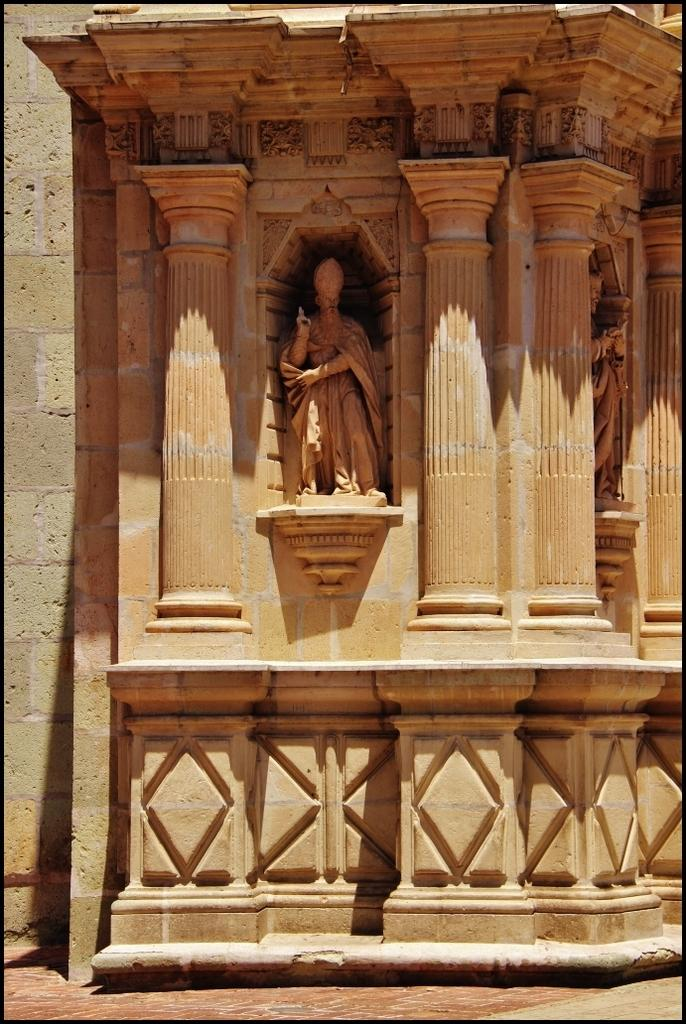What can be seen on the wall in the image? There are sculptures carved on the wall in the image. What is visible beneath the wall in the image? The ground is visible in the image. How many babies are present in the image? There are no babies present in the image. What type of material is the sculpture made of in the image? The provided facts do not mention the material of the sculpture, so we cannot determine if it is made of marble or any other material. 